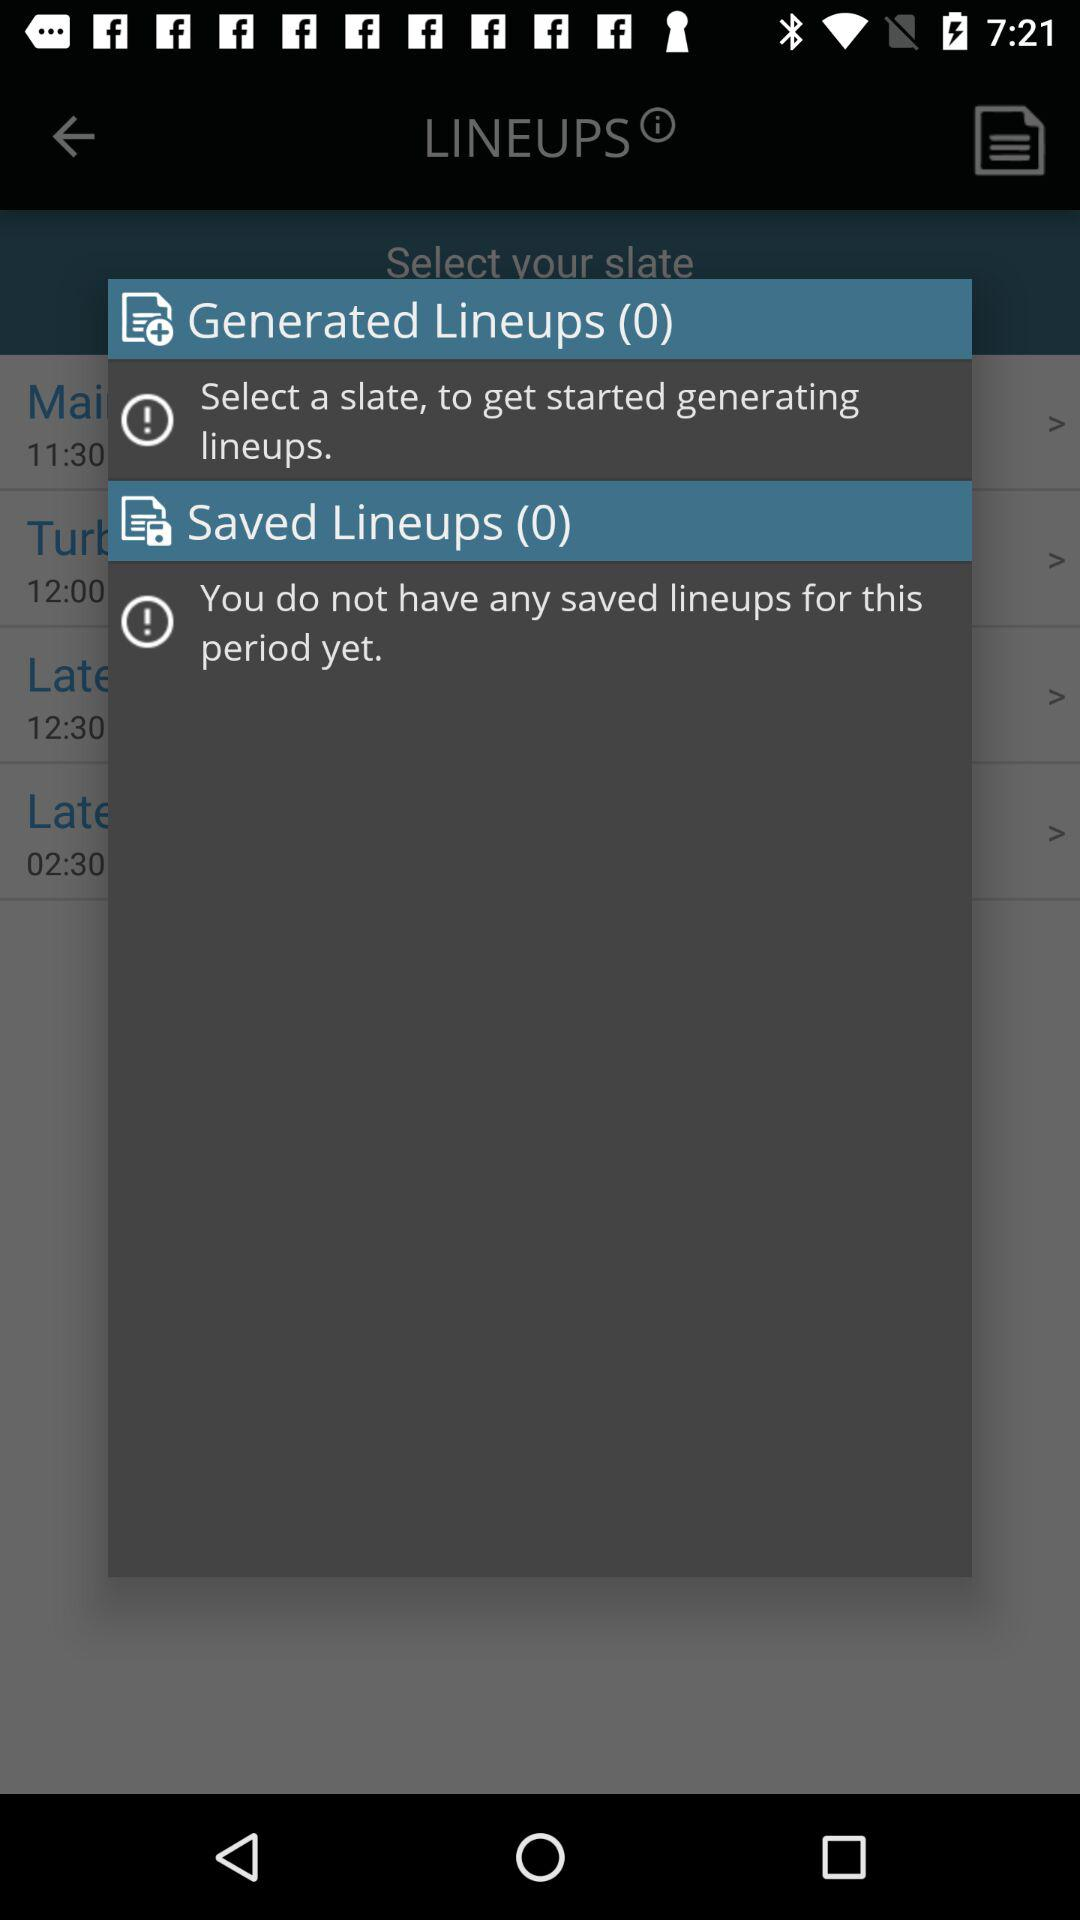What is the count of generated lineups? The count is 0. 